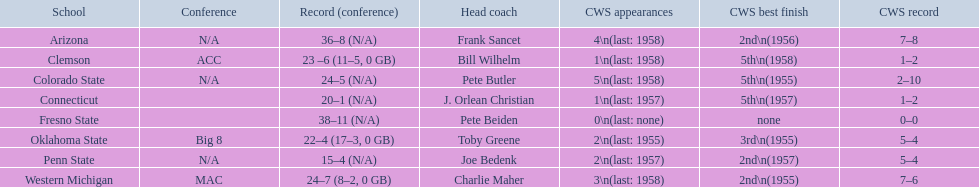During the 1959 ncaa tournament, what were the scores for each school involved? 36–8 (N/A), 23 –6 (11–5, 0 GB), 24–5 (N/A), 20–1 (N/A), 38–11 (N/A), 22–4 (17–3, 0 GB), 15–4 (N/A), 24–7 (8–2, 0 GB). What was the score that had fewer than 16 wins? 15–4 (N/A). Which team accomplished this score? Penn State. 